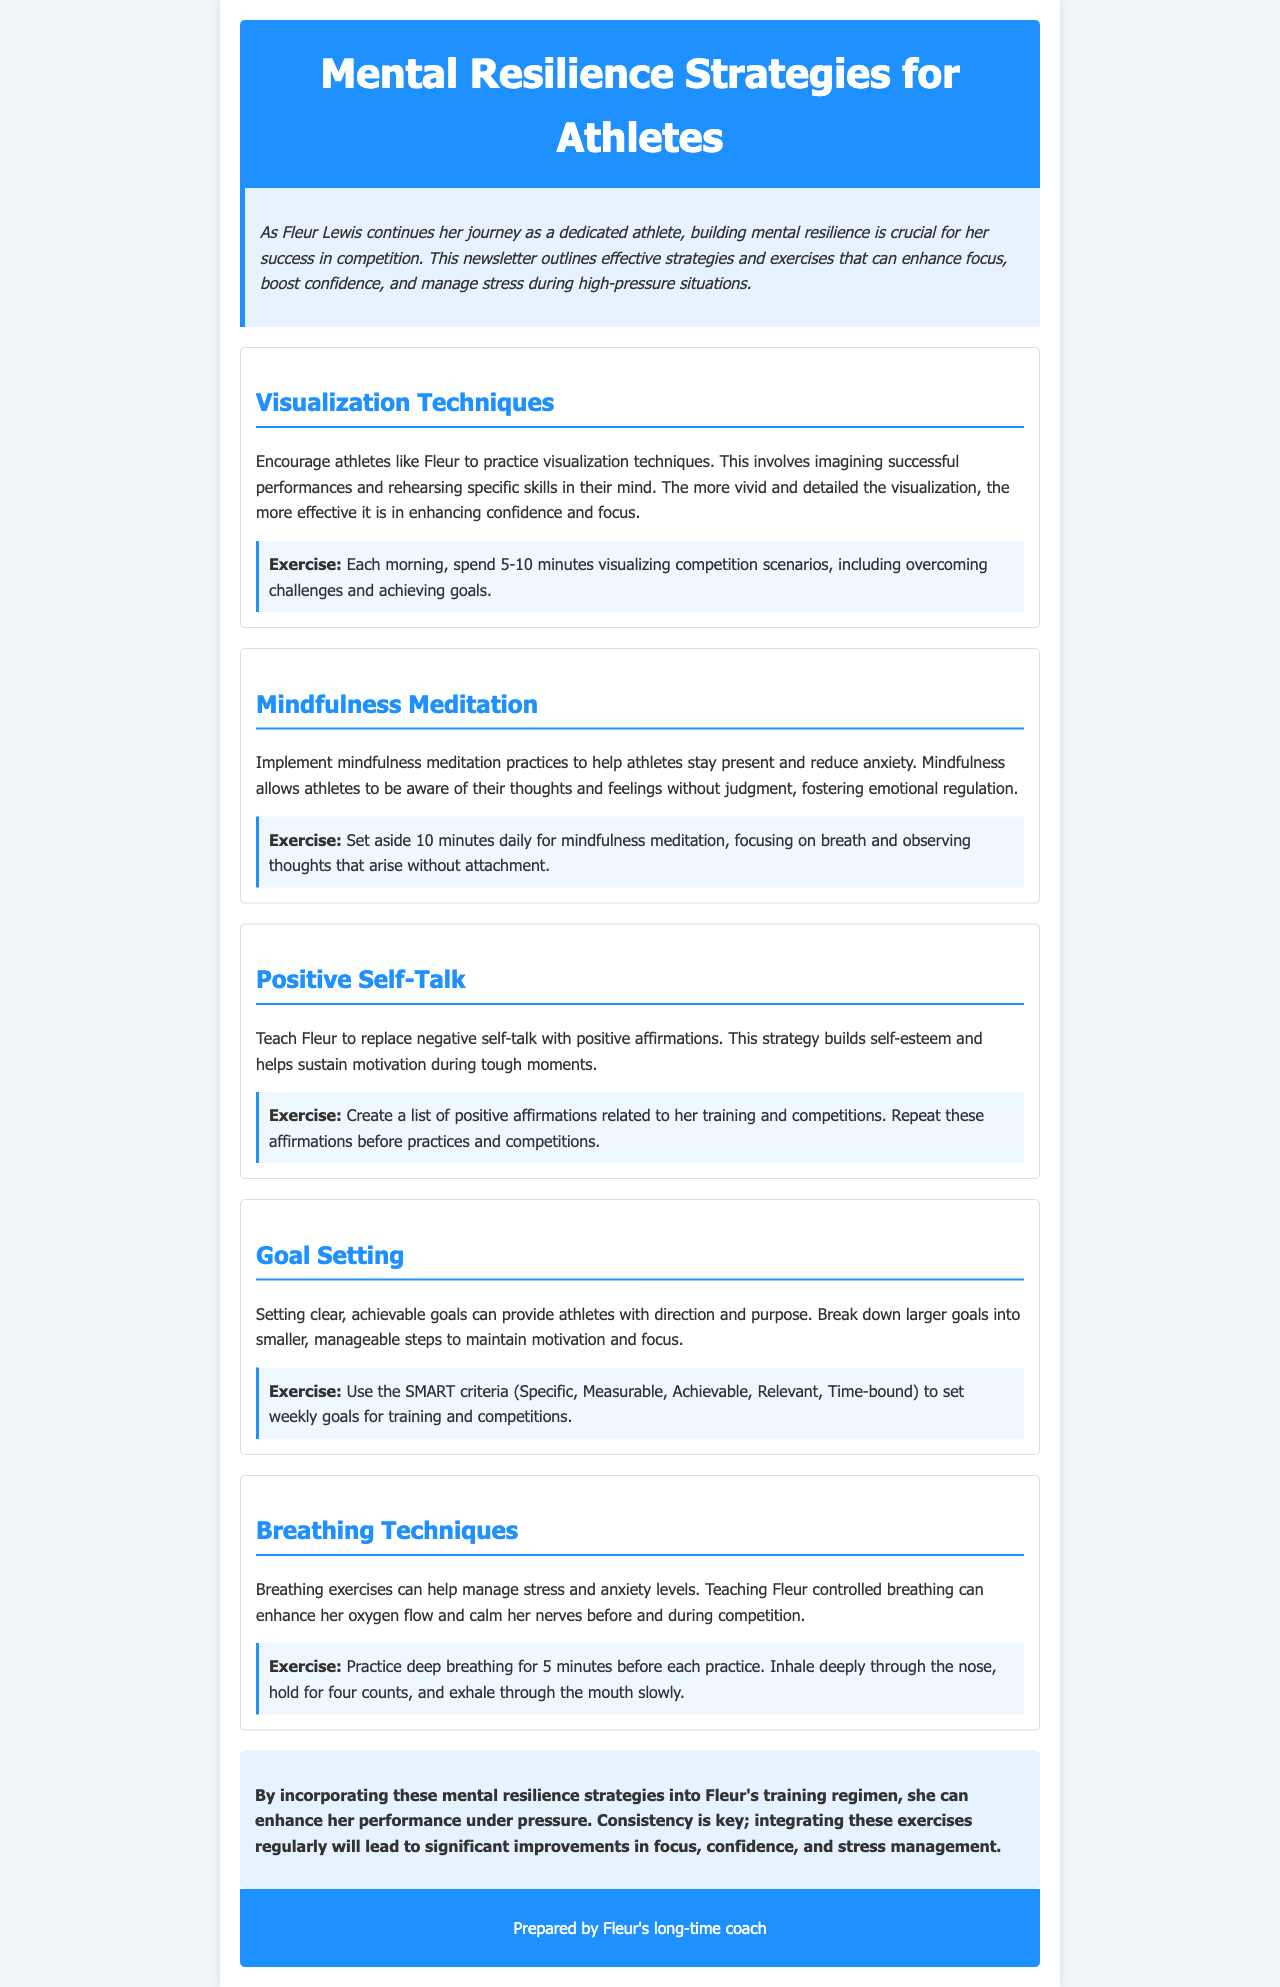What is the title of the newsletter? The title of the newsletter is found in the header section, specifically stated in the <h1> tag.
Answer: Mental Resilience Strategies for Athletes What exercise is suggested for visualization techniques? The exercise for visualization techniques is detailed within the section and provides specific instructions for practice.
Answer: Each morning, spend 5-10 minutes visualizing competition scenarios, including overcoming challenges and achieving goals How long should athletes practice mindfulness meditation daily? The duration for mindfulness meditation is explicitly mentioned in the relevant section of the document.
Answer: 10 minutes What does SMART stand for in goal setting? The acronym SMART represents a key concept in the goal-setting strategy outlined in the newsletter, defined within the text.
Answer: Specific, Measurable, Achievable, Relevant, Time-bound Which strategy is aimed at managing stress and anxiety levels? This strategy is identified in the document focused on specific techniques for stress management.
Answer: Breathing Techniques What is the main purpose of positive self-talk according to the newsletter? The purpose of positive self-talk is explained within the context of building self-esteem and motivation.
Answer: Build self-esteem and help sustain motivation How does the newsletter suggest Fleur can enhance focus? This information is gathered from multiple sections that collectively discuss techniques for enhancing focus.
Answer: By incorporating mental resilience strategies Which section contains reinforcing exercises for athletes? The section is specifically designated for detailed mental resilience strategies and corresponding exercises.
Answer: Strategies 